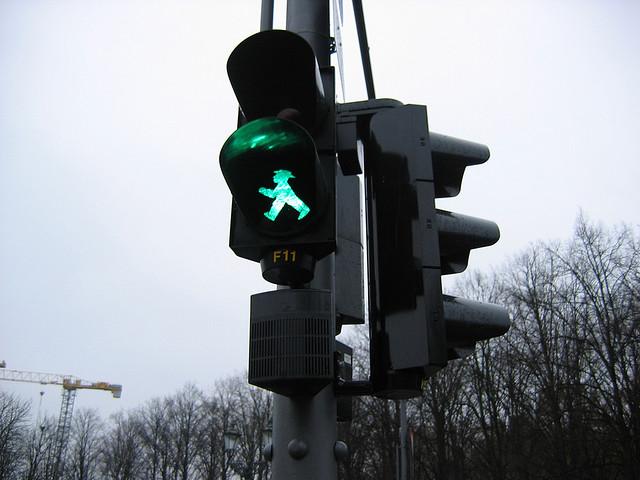What number is on the traffic signal?
Give a very brief answer. 11. What color is the traffic light?
Answer briefly. Green. Is it safe to cross the street?
Be succinct. Yes. What is on the walking icon's head?
Quick response, please. Hat. 